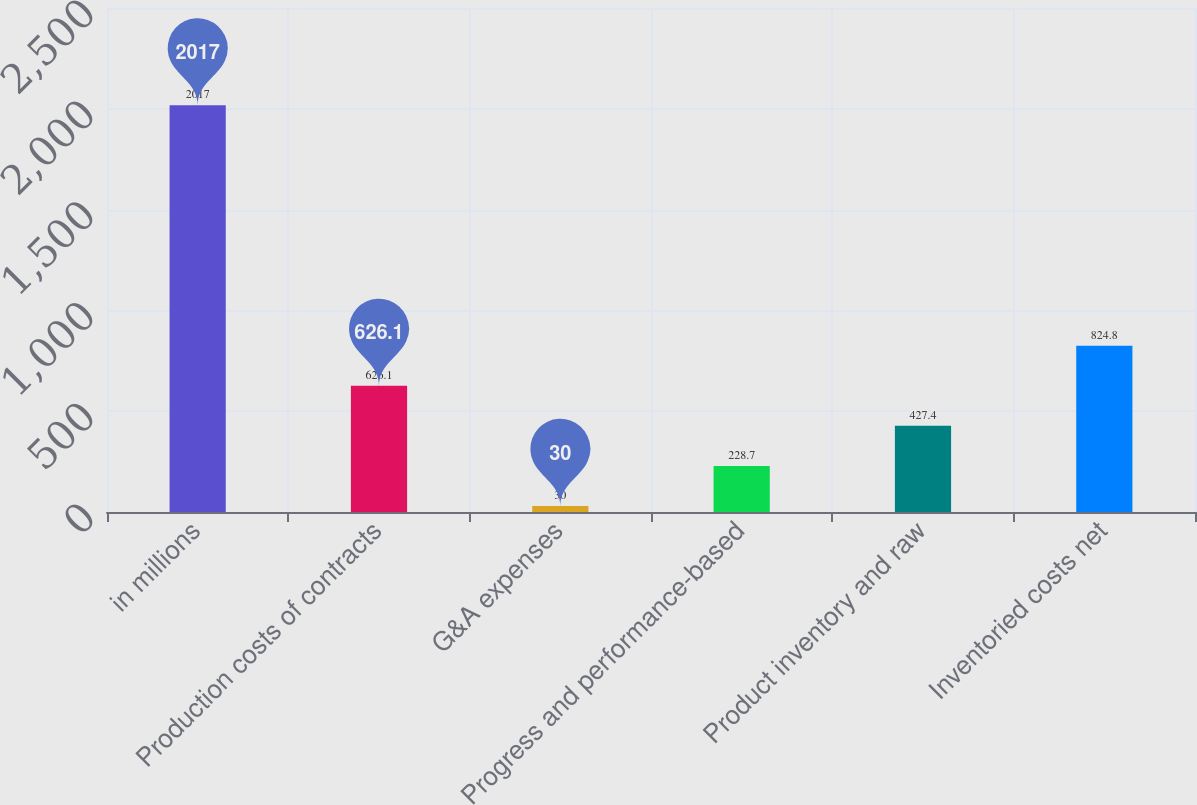<chart> <loc_0><loc_0><loc_500><loc_500><bar_chart><fcel>in millions<fcel>Production costs of contracts<fcel>G&A expenses<fcel>Progress and performance-based<fcel>Product inventory and raw<fcel>Inventoried costs net<nl><fcel>2017<fcel>626.1<fcel>30<fcel>228.7<fcel>427.4<fcel>824.8<nl></chart> 